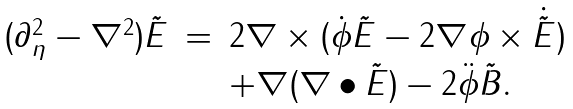Convert formula to latex. <formula><loc_0><loc_0><loc_500><loc_500>\begin{array} { l l l } ( \partial _ { \eta } ^ { 2 } - \nabla ^ { 2 } ) \tilde { E } & = & 2 \nabla \times ( \dot { \phi } \tilde { E } - 2 \nabla \phi \times \dot { \tilde { E } } ) \\ & & + \nabla ( \nabla \bullet \tilde { E } ) - 2 \ddot { \phi } \tilde { B } . \end{array}</formula> 